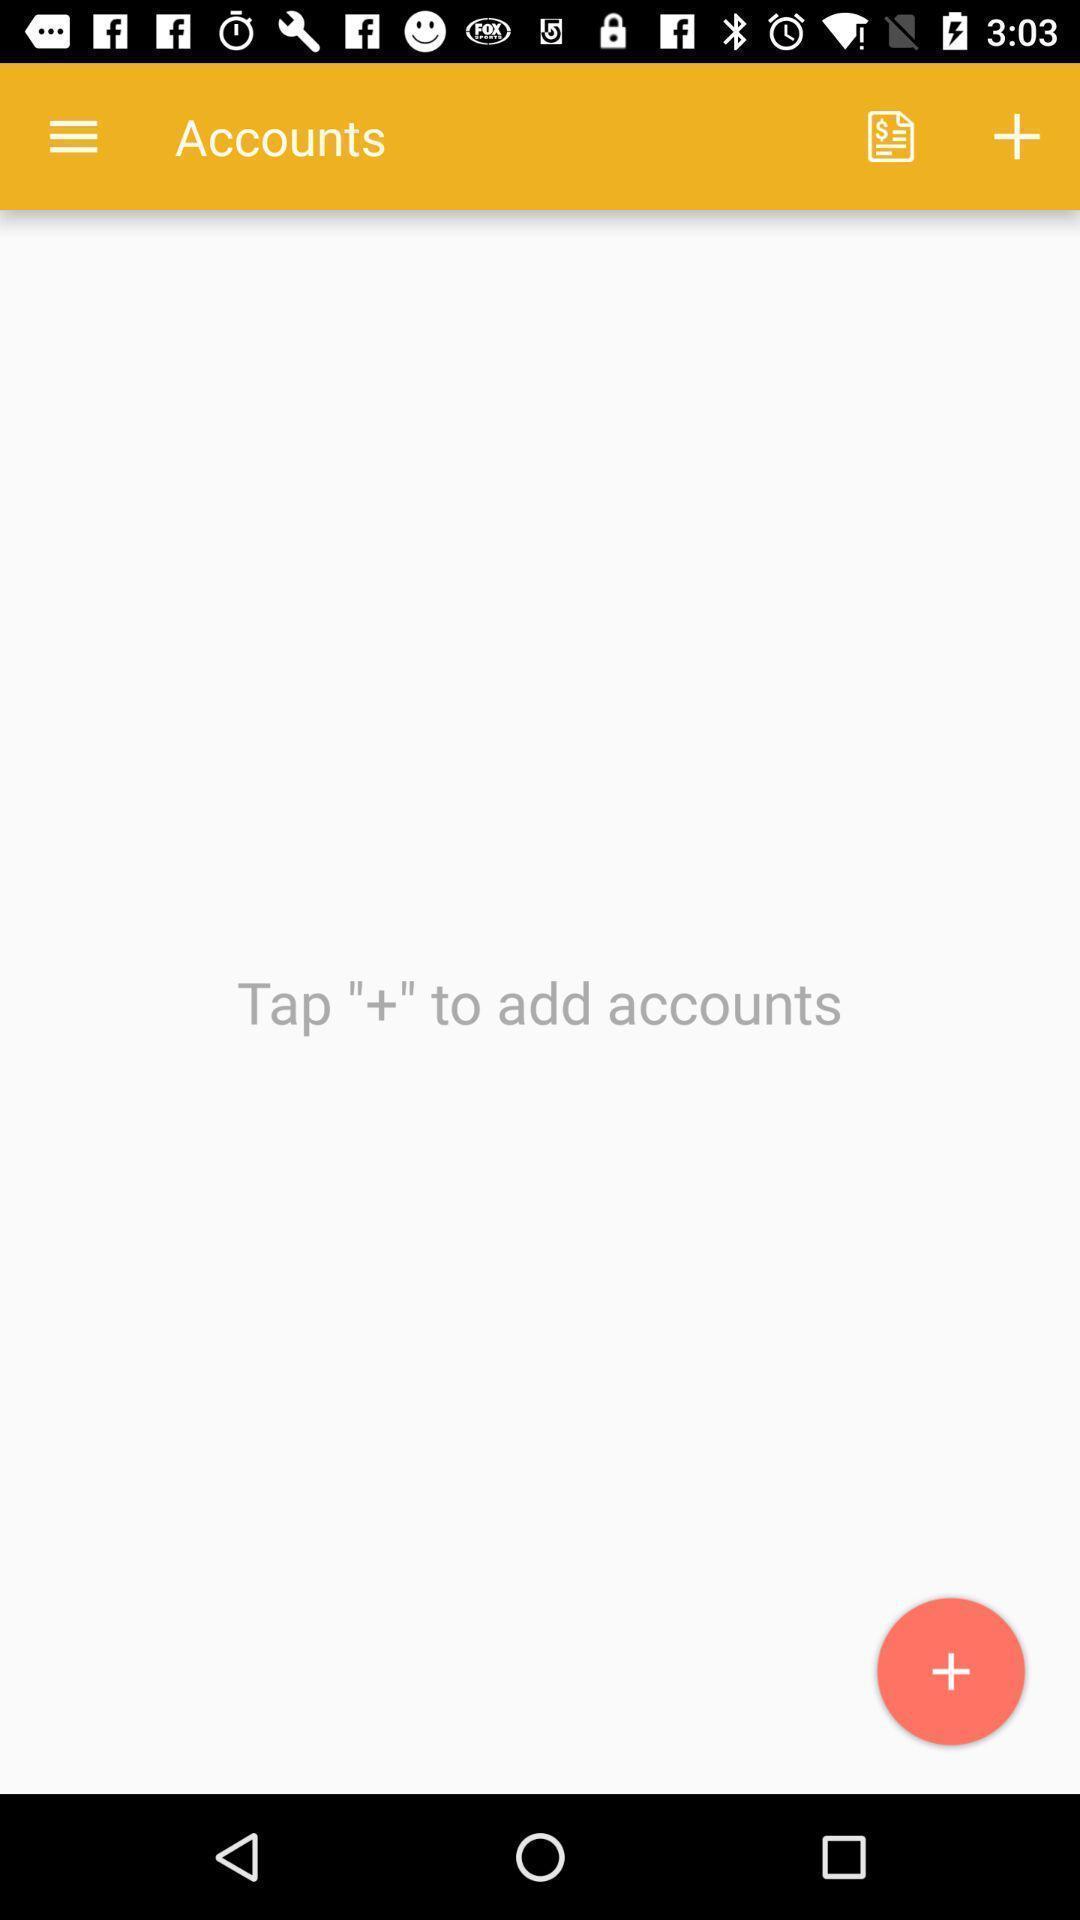Describe the key features of this screenshot. Screen page displaying add account option. 